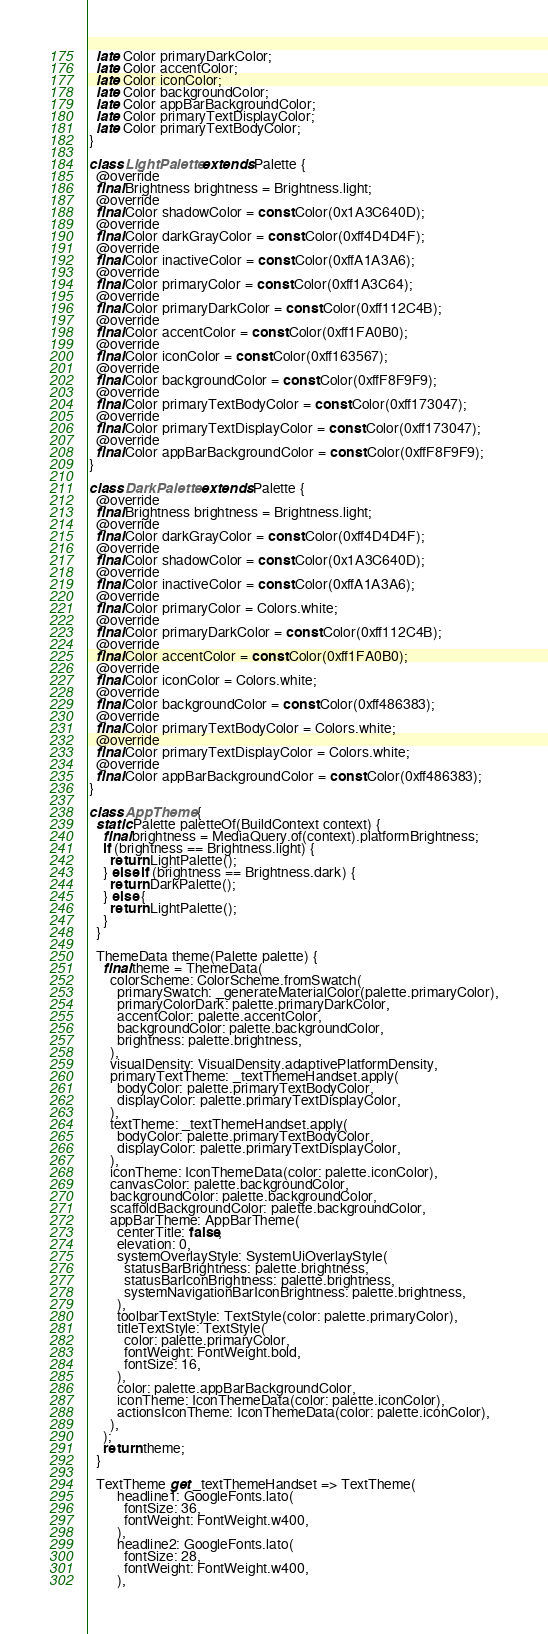Convert code to text. <code><loc_0><loc_0><loc_500><loc_500><_Dart_>  late Color primaryDarkColor;
  late Color accentColor;
  late Color iconColor;
  late Color backgroundColor;
  late Color appBarBackgroundColor;
  late Color primaryTextDisplayColor;
  late Color primaryTextBodyColor;
}

class LightPalette extends Palette {
  @override
  final Brightness brightness = Brightness.light;
  @override
  final Color shadowColor = const Color(0x1A3C640D);
  @override
  final Color darkGrayColor = const Color(0xff4D4D4F);
  @override
  final Color inactiveColor = const Color(0xffA1A3A6);
  @override
  final Color primaryColor = const Color(0xff1A3C64);
  @override
  final Color primaryDarkColor = const Color(0xff112C4B);
  @override
  final Color accentColor = const Color(0xff1FA0B0);
  @override
  final Color iconColor = const Color(0xff163567);
  @override
  final Color backgroundColor = const Color(0xffF8F9F9);
  @override
  final Color primaryTextBodyColor = const Color(0xff173047);
  @override
  final Color primaryTextDisplayColor = const Color(0xff173047);
  @override
  final Color appBarBackgroundColor = const Color(0xffF8F9F9);
}

class DarkPalette extends Palette {
  @override
  final Brightness brightness = Brightness.light;
  @override
  final Color darkGrayColor = const Color(0xff4D4D4F);
  @override
  final Color shadowColor = const Color(0x1A3C640D);
  @override
  final Color inactiveColor = const Color(0xffA1A3A6);
  @override
  final Color primaryColor = Colors.white;
  @override
  final Color primaryDarkColor = const Color(0xff112C4B);
  @override
  final Color accentColor = const Color(0xff1FA0B0);
  @override
  final Color iconColor = Colors.white;
  @override
  final Color backgroundColor = const Color(0xff486383);
  @override
  final Color primaryTextBodyColor = Colors.white;
  @override
  final Color primaryTextDisplayColor = Colors.white;
  @override
  final Color appBarBackgroundColor = const Color(0xff486383);
}

class AppTheme {
  static Palette paletteOf(BuildContext context) {
    final brightness = MediaQuery.of(context).platformBrightness;
    if (brightness == Brightness.light) {
      return LightPalette();
    } else if (brightness == Brightness.dark) {
      return DarkPalette();
    } else {
      return LightPalette();
    }
  }

  ThemeData theme(Palette palette) {
    final theme = ThemeData(
      colorScheme: ColorScheme.fromSwatch(
        primarySwatch: _generateMaterialColor(palette.primaryColor),
        primaryColorDark: palette.primaryDarkColor,
        accentColor: palette.accentColor,
        backgroundColor: palette.backgroundColor,
        brightness: palette.brightness,
      ),
      visualDensity: VisualDensity.adaptivePlatformDensity,
      primaryTextTheme: _textThemeHandset.apply(
        bodyColor: palette.primaryTextBodyColor,
        displayColor: palette.primaryTextDisplayColor,
      ),
      textTheme: _textThemeHandset.apply(
        bodyColor: palette.primaryTextBodyColor,
        displayColor: palette.primaryTextDisplayColor,
      ),
      iconTheme: IconThemeData(color: palette.iconColor),
      canvasColor: palette.backgroundColor,
      backgroundColor: palette.backgroundColor,
      scaffoldBackgroundColor: palette.backgroundColor,
      appBarTheme: AppBarTheme(
        centerTitle: false,
        elevation: 0,
        systemOverlayStyle: SystemUiOverlayStyle(
          statusBarBrightness: palette.brightness,
          statusBarIconBrightness: palette.brightness,
          systemNavigationBarIconBrightness: palette.brightness,
        ),
        toolbarTextStyle: TextStyle(color: palette.primaryColor),
        titleTextStyle: TextStyle(
          color: palette.primaryColor,
          fontWeight: FontWeight.bold,
          fontSize: 16,
        ),
        color: palette.appBarBackgroundColor,
        iconTheme: IconThemeData(color: palette.iconColor),
        actionsIconTheme: IconThemeData(color: palette.iconColor),
      ),
    );
    return theme;
  }

  TextTheme get _textThemeHandset => TextTheme(
        headline1: GoogleFonts.lato(
          fontSize: 36,
          fontWeight: FontWeight.w400,
        ),
        headline2: GoogleFonts.lato(
          fontSize: 28,
          fontWeight: FontWeight.w400,
        ),</code> 